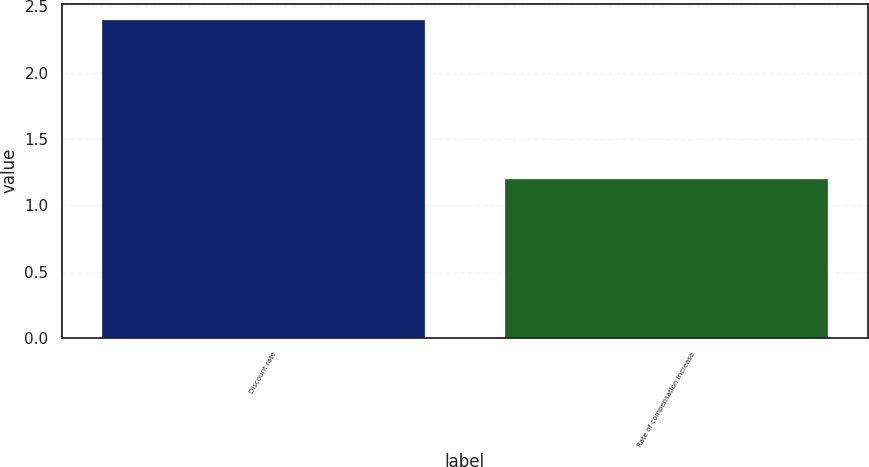Convert chart to OTSL. <chart><loc_0><loc_0><loc_500><loc_500><bar_chart><fcel>Discount rate<fcel>Rate of compensation increase<nl><fcel>2.4<fcel>1.2<nl></chart> 